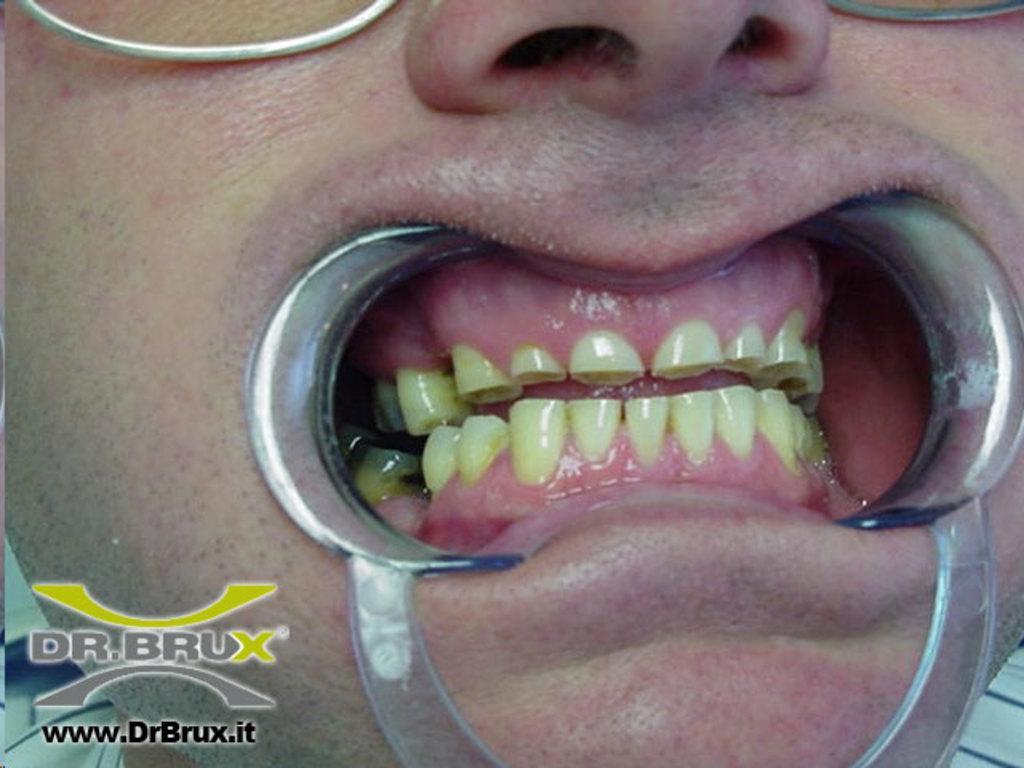Can you describe this image briefly? In this image we can see the teeth of a human being which are being operated using a dentistry. 